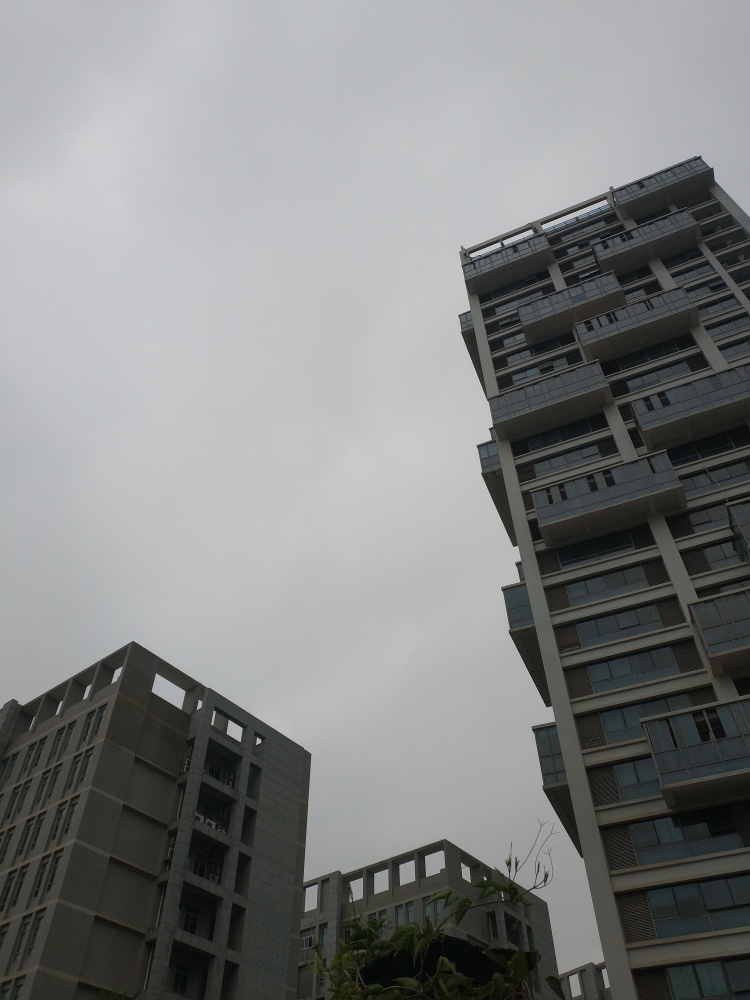How does the architecture of the buildings compare? The architecture presents a modern aesthetic with clean lines and a mix of textures. The building on the right has balconies and larger windows which may offer more natural light inside the rooms, even on cloudy days, whereas the building on the left appears more solid and uniform, possibly prioritizing privacy or structural simplicity. 